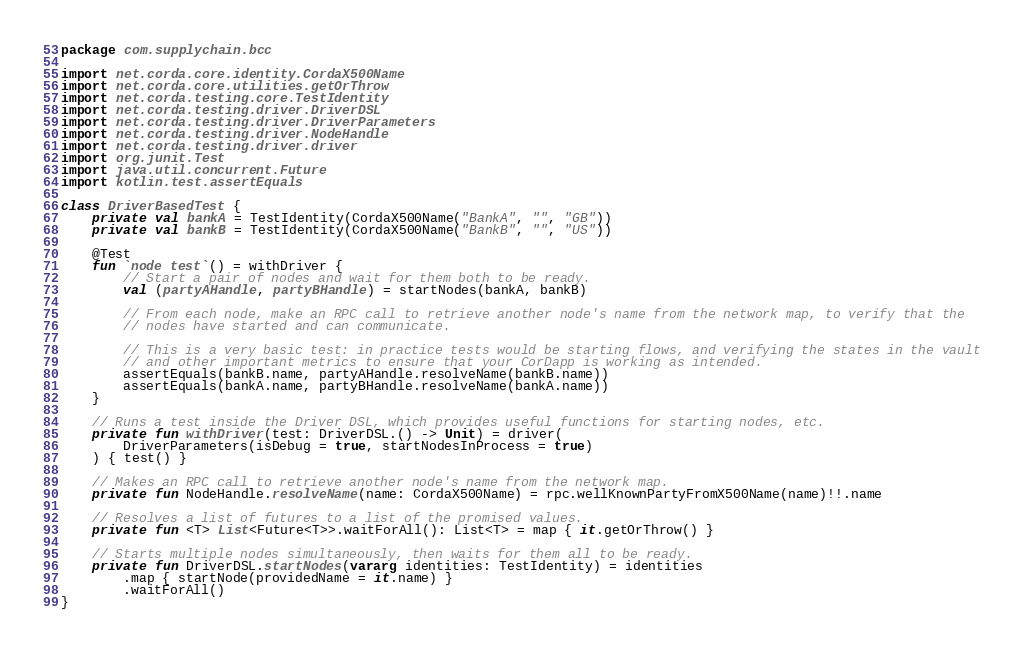Convert code to text. <code><loc_0><loc_0><loc_500><loc_500><_Kotlin_>package com.supplychain.bcc

import net.corda.core.identity.CordaX500Name
import net.corda.core.utilities.getOrThrow
import net.corda.testing.core.TestIdentity
import net.corda.testing.driver.DriverDSL
import net.corda.testing.driver.DriverParameters
import net.corda.testing.driver.NodeHandle
import net.corda.testing.driver.driver
import org.junit.Test
import java.util.concurrent.Future
import kotlin.test.assertEquals

class DriverBasedTest {
    private val bankA = TestIdentity(CordaX500Name("BankA", "", "GB"))
    private val bankB = TestIdentity(CordaX500Name("BankB", "", "US"))

    @Test
    fun `node test`() = withDriver {
        // Start a pair of nodes and wait for them both to be ready.
        val (partyAHandle, partyBHandle) = startNodes(bankA, bankB)

        // From each node, make an RPC call to retrieve another node's name from the network map, to verify that the
        // nodes have started and can communicate.

        // This is a very basic test: in practice tests would be starting flows, and verifying the states in the vault
        // and other important metrics to ensure that your CorDapp is working as intended.
        assertEquals(bankB.name, partyAHandle.resolveName(bankB.name))
        assertEquals(bankA.name, partyBHandle.resolveName(bankA.name))
    }

    // Runs a test inside the Driver DSL, which provides useful functions for starting nodes, etc.
    private fun withDriver(test: DriverDSL.() -> Unit) = driver(
        DriverParameters(isDebug = true, startNodesInProcess = true)
    ) { test() }

    // Makes an RPC call to retrieve another node's name from the network map.
    private fun NodeHandle.resolveName(name: CordaX500Name) = rpc.wellKnownPartyFromX500Name(name)!!.name

    // Resolves a list of futures to a list of the promised values.
    private fun <T> List<Future<T>>.waitForAll(): List<T> = map { it.getOrThrow() }

    // Starts multiple nodes simultaneously, then waits for them all to be ready.
    private fun DriverDSL.startNodes(vararg identities: TestIdentity) = identities
        .map { startNode(providedName = it.name) }
        .waitForAll()
}</code> 